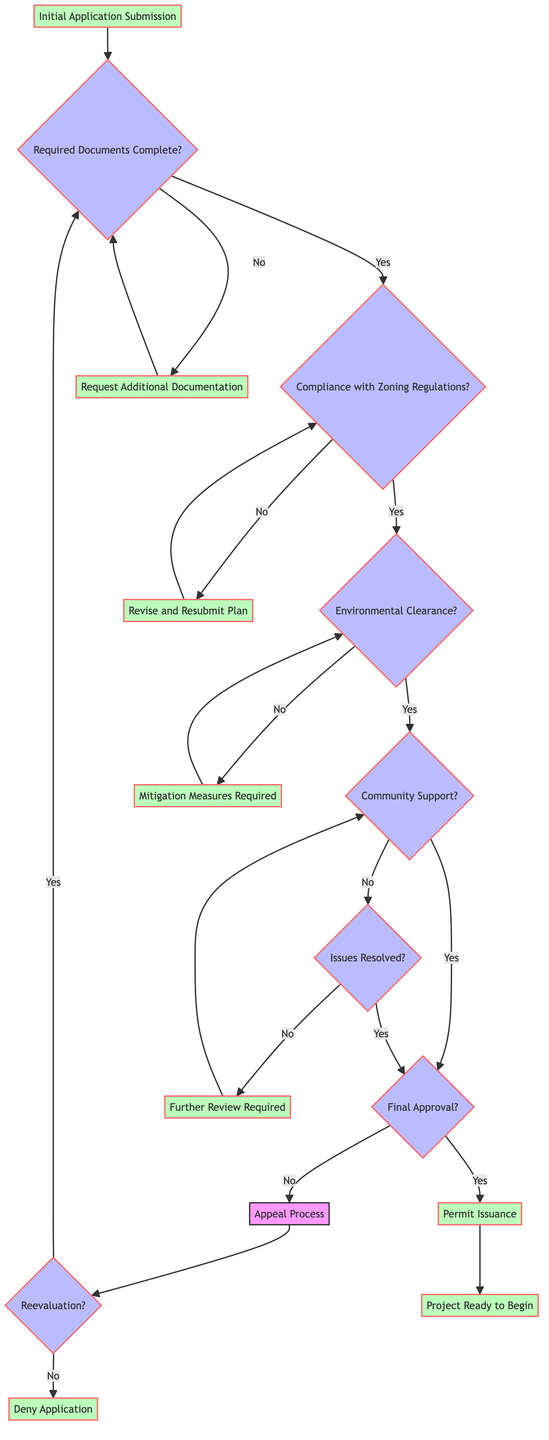What is the first step in the permitting process? The first step in the permitting process is the "Initial Application Submission," which is clearly indicated as the starting node in the diagram.
Answer: Initial Application Submission How many decision nodes are present in the diagram? By counting the nodes labeled with a question mark, we find there are six decision nodes in the diagram: "Required Documents Complete?", "Compliance with Zoning Regulations?", "Environmental Clearance?", "Community Support?", "Final Approval?", and "Issues Resolved?".
Answer: 6 What happens if the community support is not received? If community support is not received, the process flows to "Hold Public Hearing", which is indicated as the next step when the answer to the community support question is "No".
Answer: Hold Public Hearing What is required if there is no environmental clearance? If there is no environmental clearance, the next step indicated is "Mitigation Measures Required", which is the consequence of failing the environmental clearance question.
Answer: Mitigation Measures Required What outcome follows the approval by the Planning Commission? After the approval by the Planning Commission, the diagram shows "Permit Issuance" as the following step, indicating that the project can proceed toward permit issuance once final approval is granted.
Answer: Permit Issuance What happens if additional documentation is needed? If additional documentation is deemed necessary, the diagram shows that the next step would be to "Request Additional Documentation", and once that is received, the process returns to the "Required Documents Complete?" decision point.
Answer: Request Additional Documentation What are the two possibilities after the appeal process? Following the appeal process, the outcomes are either "Reevaluation" or "Deny Application"; if reevaluation occurs, the process loops back to the "Initial Application Submission" and if not, the application is denied.
Answer: Reevaluation or Deny Application What does "Project Ready to Begin" signify in the process? "Project Ready to Begin" is the final outcome after "Permit Issuance", signaling that all previous steps have been successfully completed, and the project can now commence.
Answer: Project Ready to Begin 